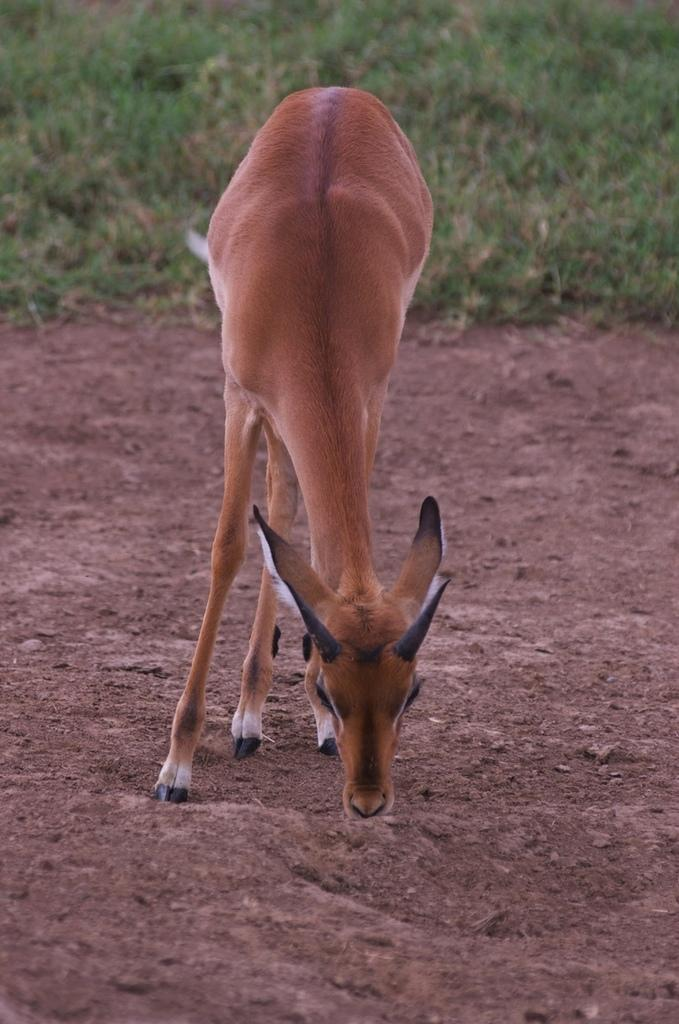What type of animal is in the picture? There is a donkey in the picture. Where is the donkey located in the image? The donkey is on the ground. What can be seen in the background of the picture? There is grass visible in the background of the picture. What type of brick structure can be seen behind the donkey in the image? There is no brick structure visible behind the donkey in the image; it is only surrounded by grass. 